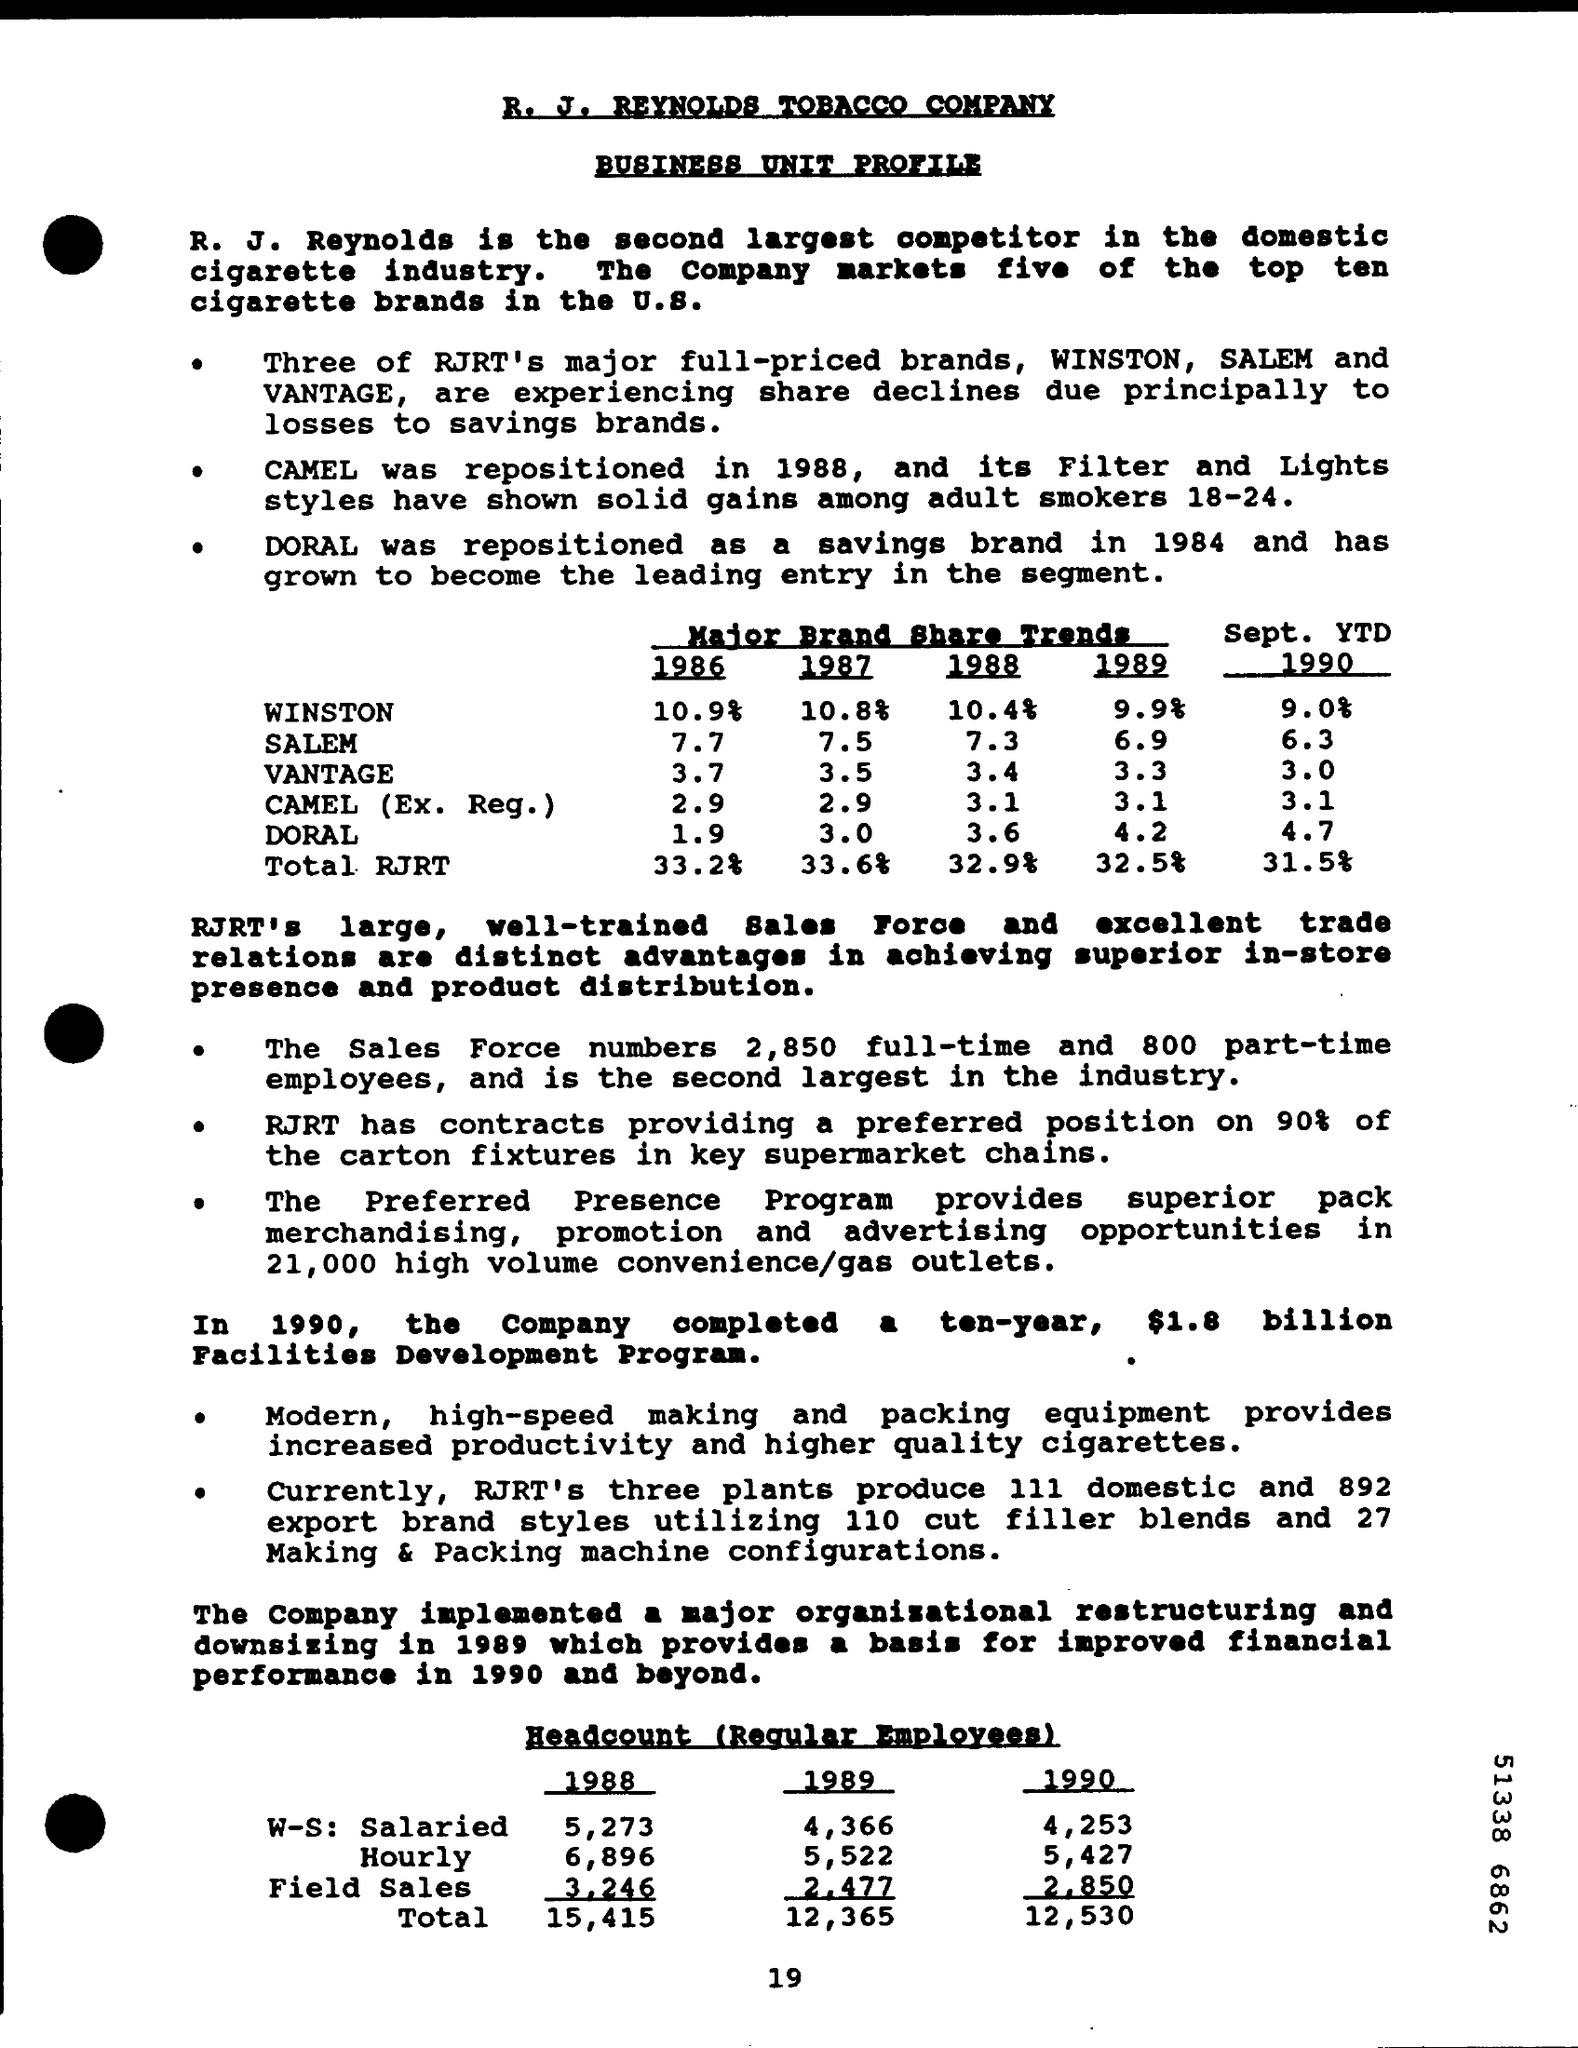What is the total RJRT brand share percentage in the year 1986?
Your response must be concise. 33.2%. What is the total RJRT brand share percentage in the year 1988?
Offer a terse response. 32.9%. What is the WINSTON brand share percentage in the year 1987?
Provide a short and direct response. 10.8%. Which RJRT brand is repositoned as a savings brand in 1984?
Offer a terse response. DORAL. What is the total headcount of regular employees for the year 1988?
Your answer should be compact. 15,415. What is the total headcount of regular employees for the year 1990?
Your response must be concise. 12,530. What is the total headcount of regular employees for the year 1989?
Ensure brevity in your answer.  12,365. 